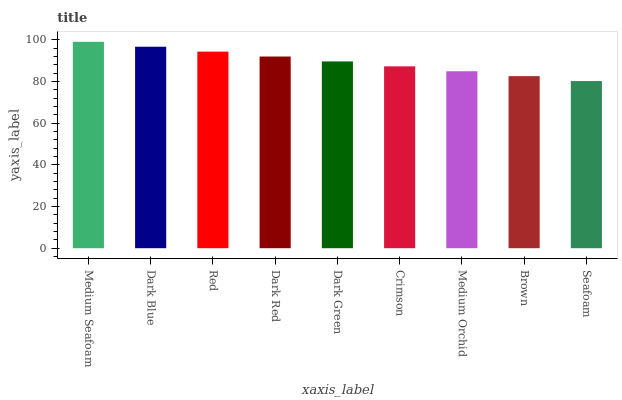Is Seafoam the minimum?
Answer yes or no. Yes. Is Medium Seafoam the maximum?
Answer yes or no. Yes. Is Dark Blue the minimum?
Answer yes or no. No. Is Dark Blue the maximum?
Answer yes or no. No. Is Medium Seafoam greater than Dark Blue?
Answer yes or no. Yes. Is Dark Blue less than Medium Seafoam?
Answer yes or no. Yes. Is Dark Blue greater than Medium Seafoam?
Answer yes or no. No. Is Medium Seafoam less than Dark Blue?
Answer yes or no. No. Is Dark Green the high median?
Answer yes or no. Yes. Is Dark Green the low median?
Answer yes or no. Yes. Is Crimson the high median?
Answer yes or no. No. Is Medium Seafoam the low median?
Answer yes or no. No. 